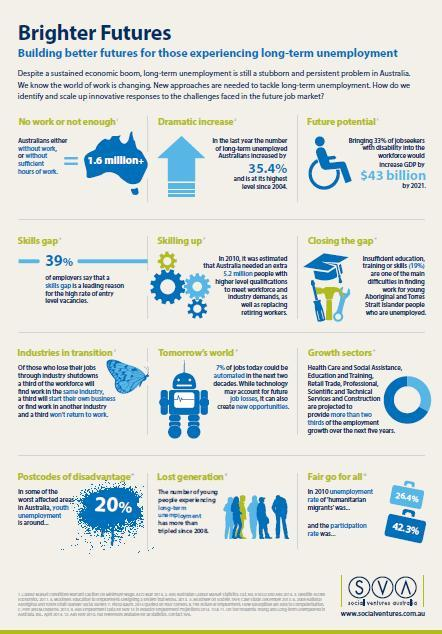which area does the butterfly denote
Answer the question with a short phrase. industries in transition how many are with no work or not enough work 1.6 million+ what is the disabled percentage that need to be brought back to work force 33% what is the difference between unemployment rate and participation rate in 2010 15.9 what area does the robot show tomorrow's world 